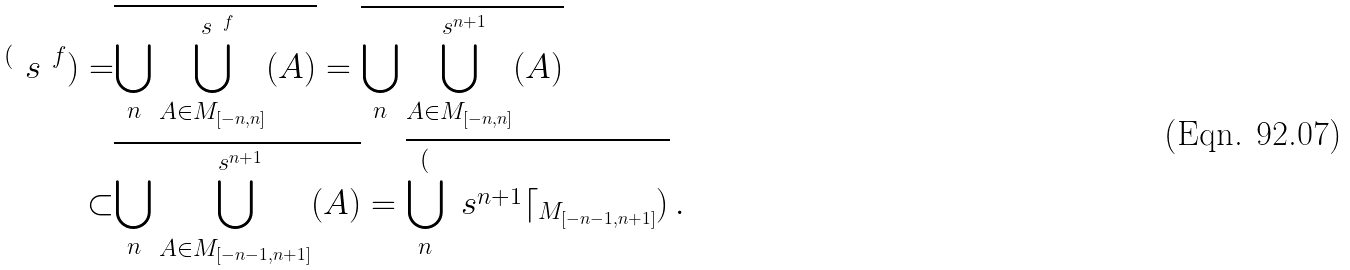<formula> <loc_0><loc_0><loc_500><loc_500>^ { ( } \ s ^ { \ f } ) = & \overline { \bigcup _ { n } \bigcup _ { A \in M _ { [ - n , n ] } } ^ { \ s ^ { \ f } } ( A ) } = \overline { \bigcup _ { n } \bigcup _ { A \in M _ { [ - n , n ] } } ^ { \ s ^ { n + 1 } } ( A ) } \\ \subset & \overline { \bigcup _ { n } \bigcup _ { A \in M _ { [ - n - 1 , n + 1 ] } } ^ { \ s ^ { n + 1 } } ( A ) } = \overline { \bigcup _ { n } ^ { ( } \ s ^ { n + 1 } \lceil _ { M _ { [ - n - 1 , n + 1 ] } } ) } \, .</formula> 